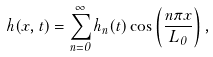<formula> <loc_0><loc_0><loc_500><loc_500>h ( x , t ) = \sum _ { n = 0 } ^ { \infty } h _ { n } ( t ) \cos \left ( \frac { n \pi x } { L _ { 0 } } \right ) ,</formula> 